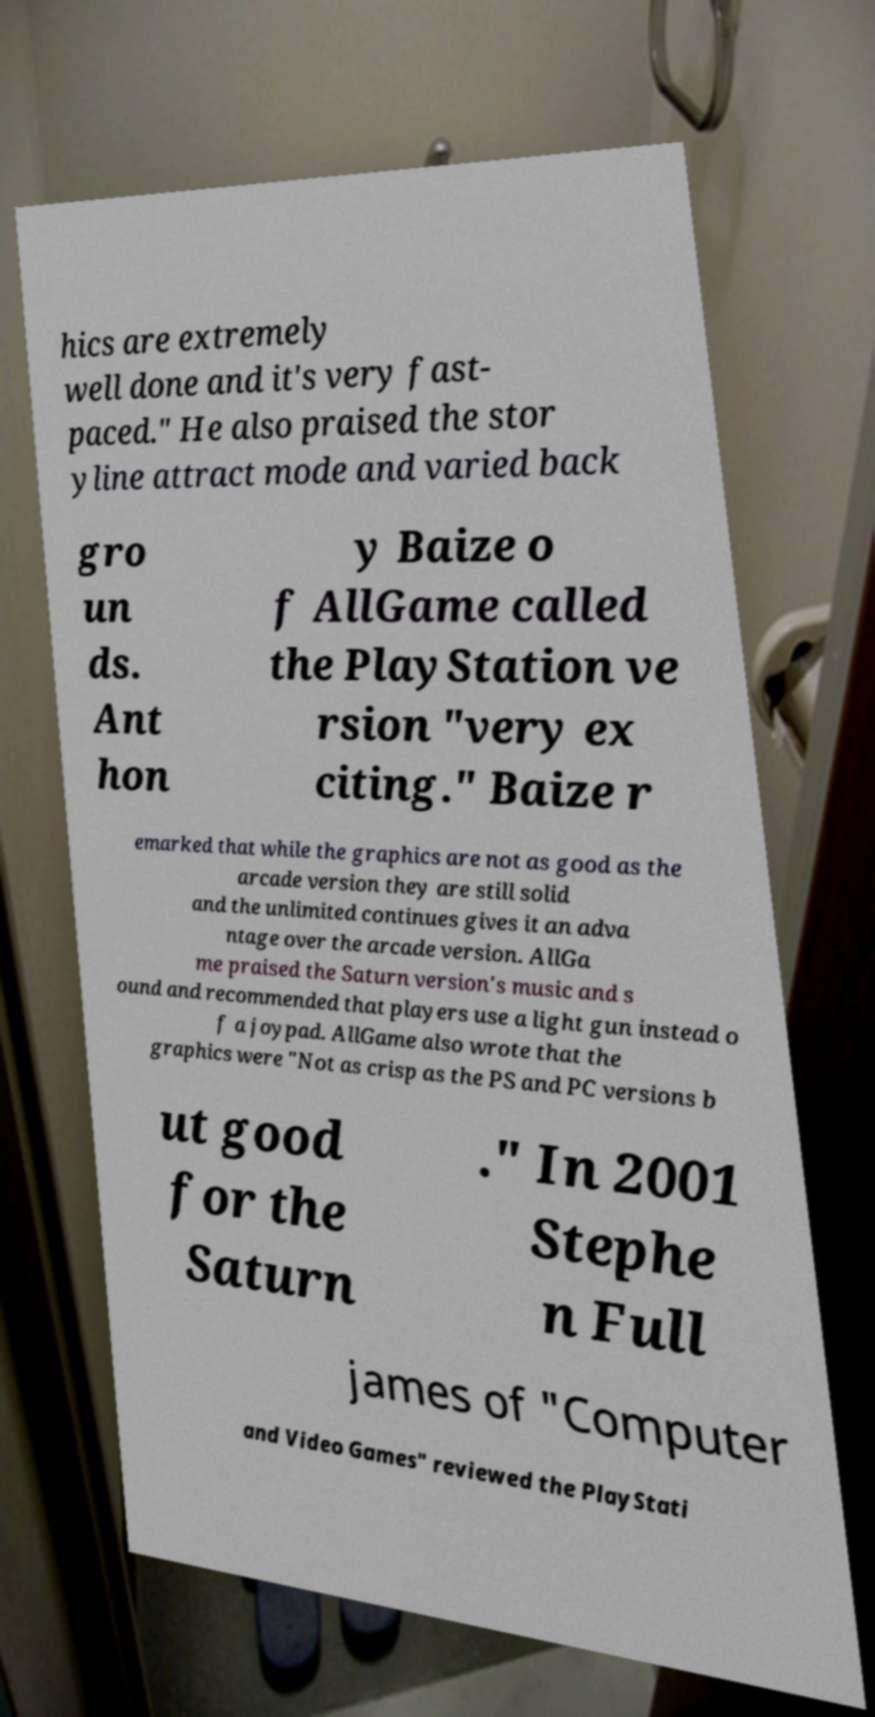Can you accurately transcribe the text from the provided image for me? hics are extremely well done and it's very fast- paced." He also praised the stor yline attract mode and varied back gro un ds. Ant hon y Baize o f AllGame called the PlayStation ve rsion "very ex citing." Baize r emarked that while the graphics are not as good as the arcade version they are still solid and the unlimited continues gives it an adva ntage over the arcade version. AllGa me praised the Saturn version's music and s ound and recommended that players use a light gun instead o f a joypad. AllGame also wrote that the graphics were "Not as crisp as the PS and PC versions b ut good for the Saturn ." In 2001 Stephe n Full james of "Computer and Video Games" reviewed the PlayStati 